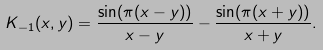Convert formula to latex. <formula><loc_0><loc_0><loc_500><loc_500>K _ { - 1 } ( x , y ) = \frac { \sin ( \pi ( x - y ) ) } { x - y } - \frac { \sin ( \pi ( x + y ) ) } { x + y } .</formula> 